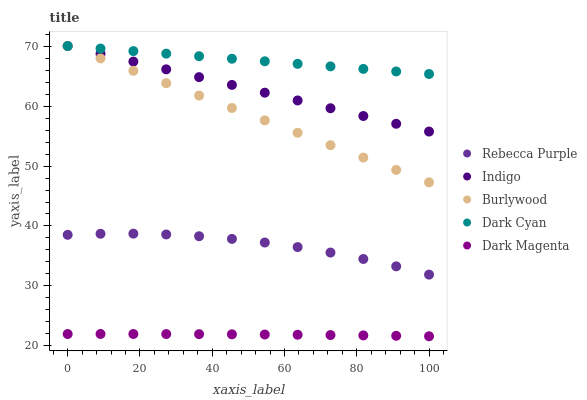Does Dark Magenta have the minimum area under the curve?
Answer yes or no. Yes. Does Dark Cyan have the maximum area under the curve?
Answer yes or no. Yes. Does Indigo have the minimum area under the curve?
Answer yes or no. No. Does Indigo have the maximum area under the curve?
Answer yes or no. No. Is Indigo the smoothest?
Answer yes or no. Yes. Is Rebecca Purple the roughest?
Answer yes or no. Yes. Is Dark Cyan the smoothest?
Answer yes or no. No. Is Dark Cyan the roughest?
Answer yes or no. No. Does Dark Magenta have the lowest value?
Answer yes or no. Yes. Does Indigo have the lowest value?
Answer yes or no. No. Does Indigo have the highest value?
Answer yes or no. Yes. Does Rebecca Purple have the highest value?
Answer yes or no. No. Is Dark Magenta less than Indigo?
Answer yes or no. Yes. Is Indigo greater than Rebecca Purple?
Answer yes or no. Yes. Does Dark Cyan intersect Burlywood?
Answer yes or no. Yes. Is Dark Cyan less than Burlywood?
Answer yes or no. No. Is Dark Cyan greater than Burlywood?
Answer yes or no. No. Does Dark Magenta intersect Indigo?
Answer yes or no. No. 